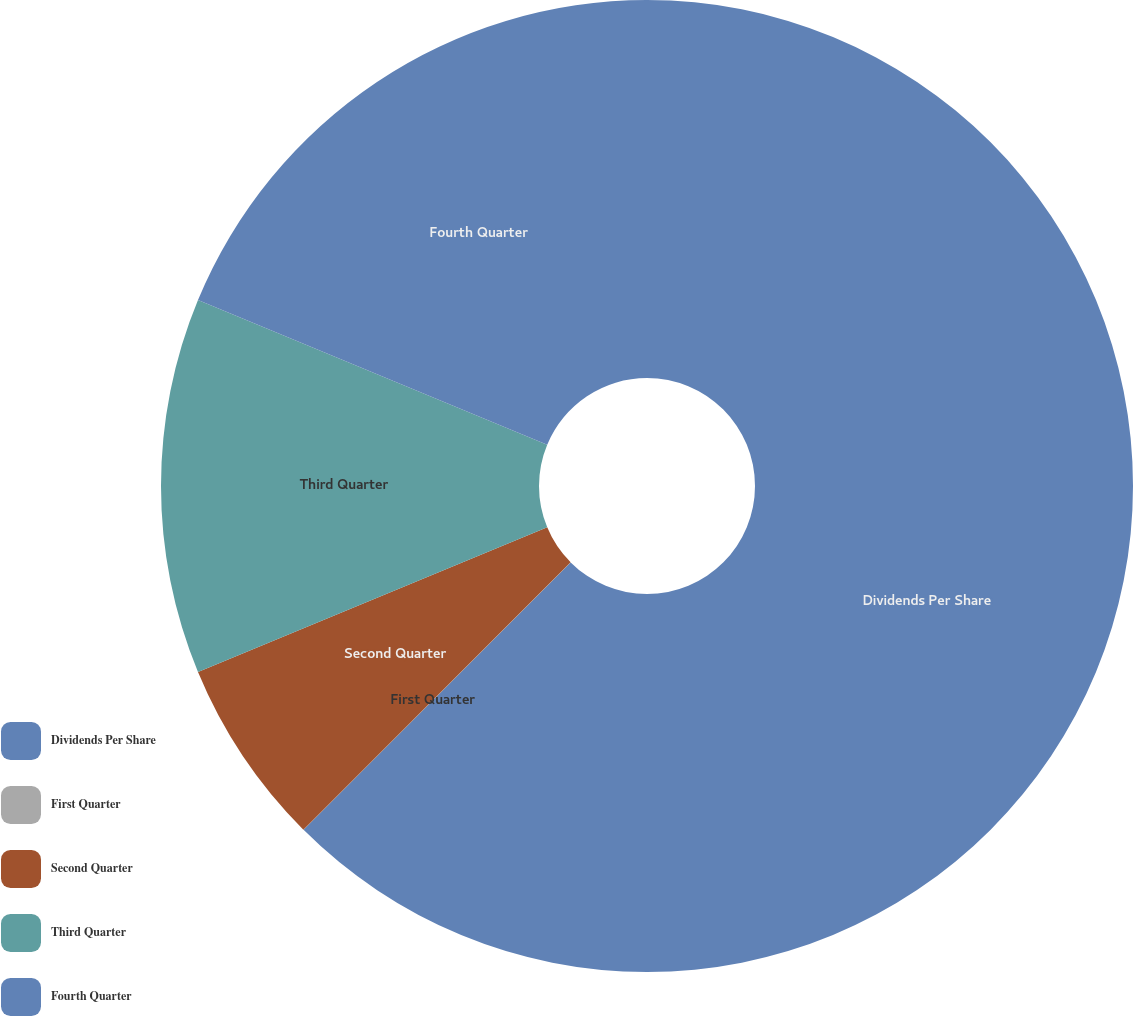Convert chart to OTSL. <chart><loc_0><loc_0><loc_500><loc_500><pie_chart><fcel>Dividends Per Share<fcel>First Quarter<fcel>Second Quarter<fcel>Third Quarter<fcel>Fourth Quarter<nl><fcel>62.49%<fcel>0.01%<fcel>6.25%<fcel>12.5%<fcel>18.75%<nl></chart> 